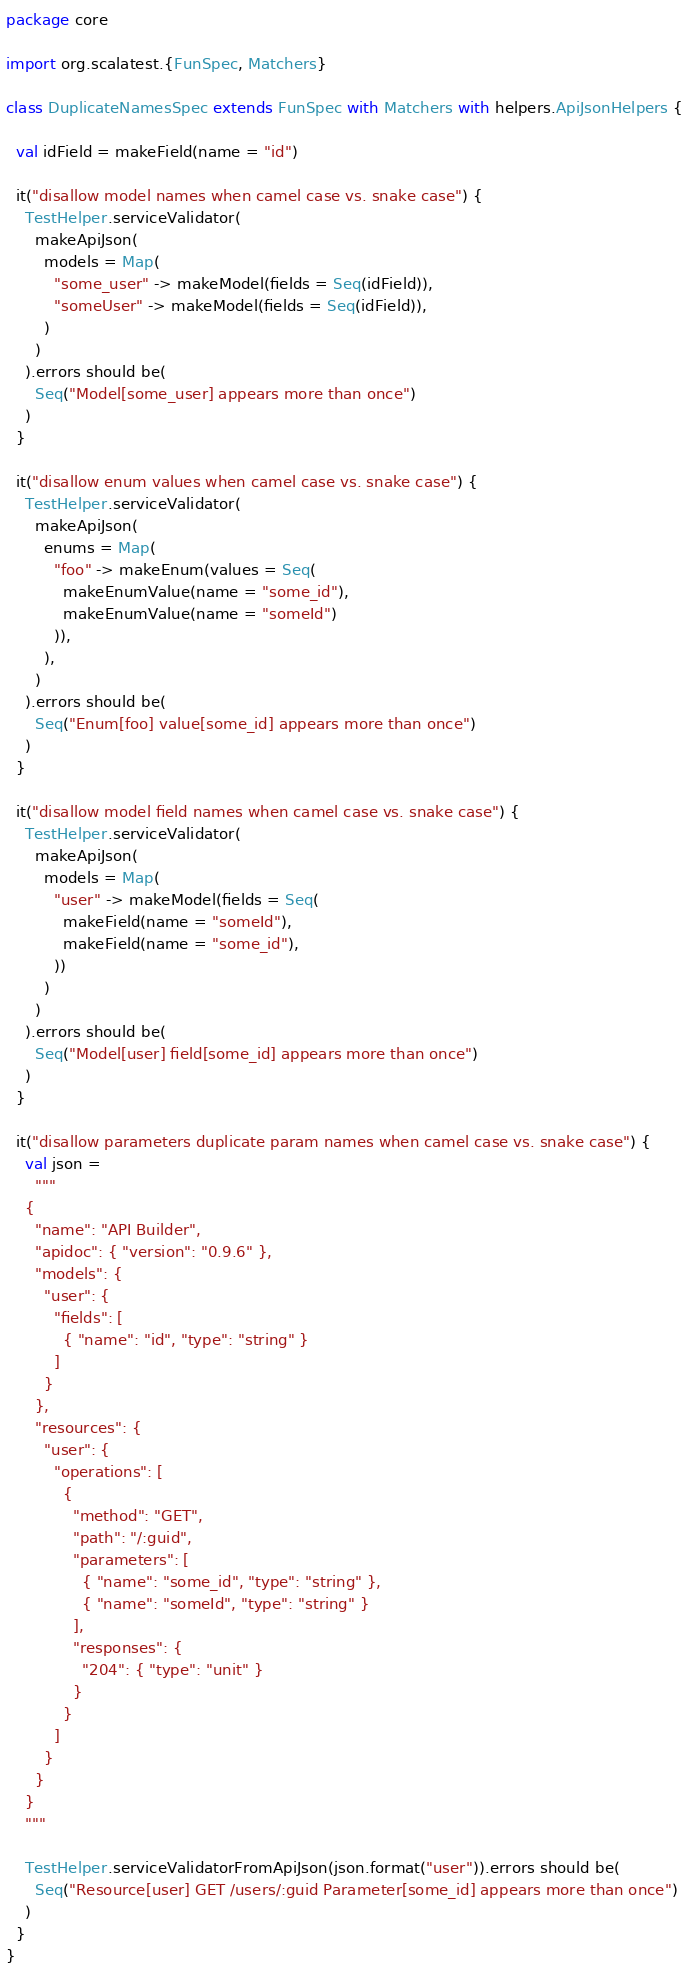<code> <loc_0><loc_0><loc_500><loc_500><_Scala_>package core

import org.scalatest.{FunSpec, Matchers}

class DuplicateNamesSpec extends FunSpec with Matchers with helpers.ApiJsonHelpers {

  val idField = makeField(name = "id")

  it("disallow model names when camel case vs. snake case") {
    TestHelper.serviceValidator(
      makeApiJson(
        models = Map(
          "some_user" -> makeModel(fields = Seq(idField)),
          "someUser" -> makeModel(fields = Seq(idField)),
        )
      )
    ).errors should be(
      Seq("Model[some_user] appears more than once")
    )
  }

  it("disallow enum values when camel case vs. snake case") {
    TestHelper.serviceValidator(
      makeApiJson(
        enums = Map(
          "foo" -> makeEnum(values = Seq(
            makeEnumValue(name = "some_id"),
            makeEnumValue(name = "someId")
          )),
        ),
      )
    ).errors should be(
      Seq("Enum[foo] value[some_id] appears more than once")
    )
  }

  it("disallow model field names when camel case vs. snake case") {
    TestHelper.serviceValidator(
      makeApiJson(
        models = Map(
          "user" -> makeModel(fields = Seq(
            makeField(name = "someId"),
            makeField(name = "some_id"),
          ))
        )
      )
    ).errors should be(
      Seq("Model[user] field[some_id] appears more than once")
    )
  }

  it("disallow parameters duplicate param names when camel case vs. snake case") {
    val json =
      """
    {
      "name": "API Builder",
      "apidoc": { "version": "0.9.6" },
      "models": {
        "user": {
          "fields": [
            { "name": "id", "type": "string" }
          ]
        }
      },
      "resources": {
        "user": {
          "operations": [
            {
              "method": "GET",
              "path": "/:guid",
              "parameters": [
                { "name": "some_id", "type": "string" },
                { "name": "someId", "type": "string" }
              ],
              "responses": {
                "204": { "type": "unit" }
              }
            }
          ]
        }
      }
    }
    """

    TestHelper.serviceValidatorFromApiJson(json.format("user")).errors should be(
      Seq("Resource[user] GET /users/:guid Parameter[some_id] appears more than once")
    )
  }
}
</code> 